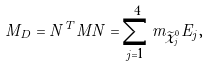Convert formula to latex. <formula><loc_0><loc_0><loc_500><loc_500>M _ { D } = N ^ { T } M N = \sum _ { j = 1 } ^ { 4 } m _ { \widetilde { \chi } _ { j } ^ { 0 } } E _ { j } ,</formula> 